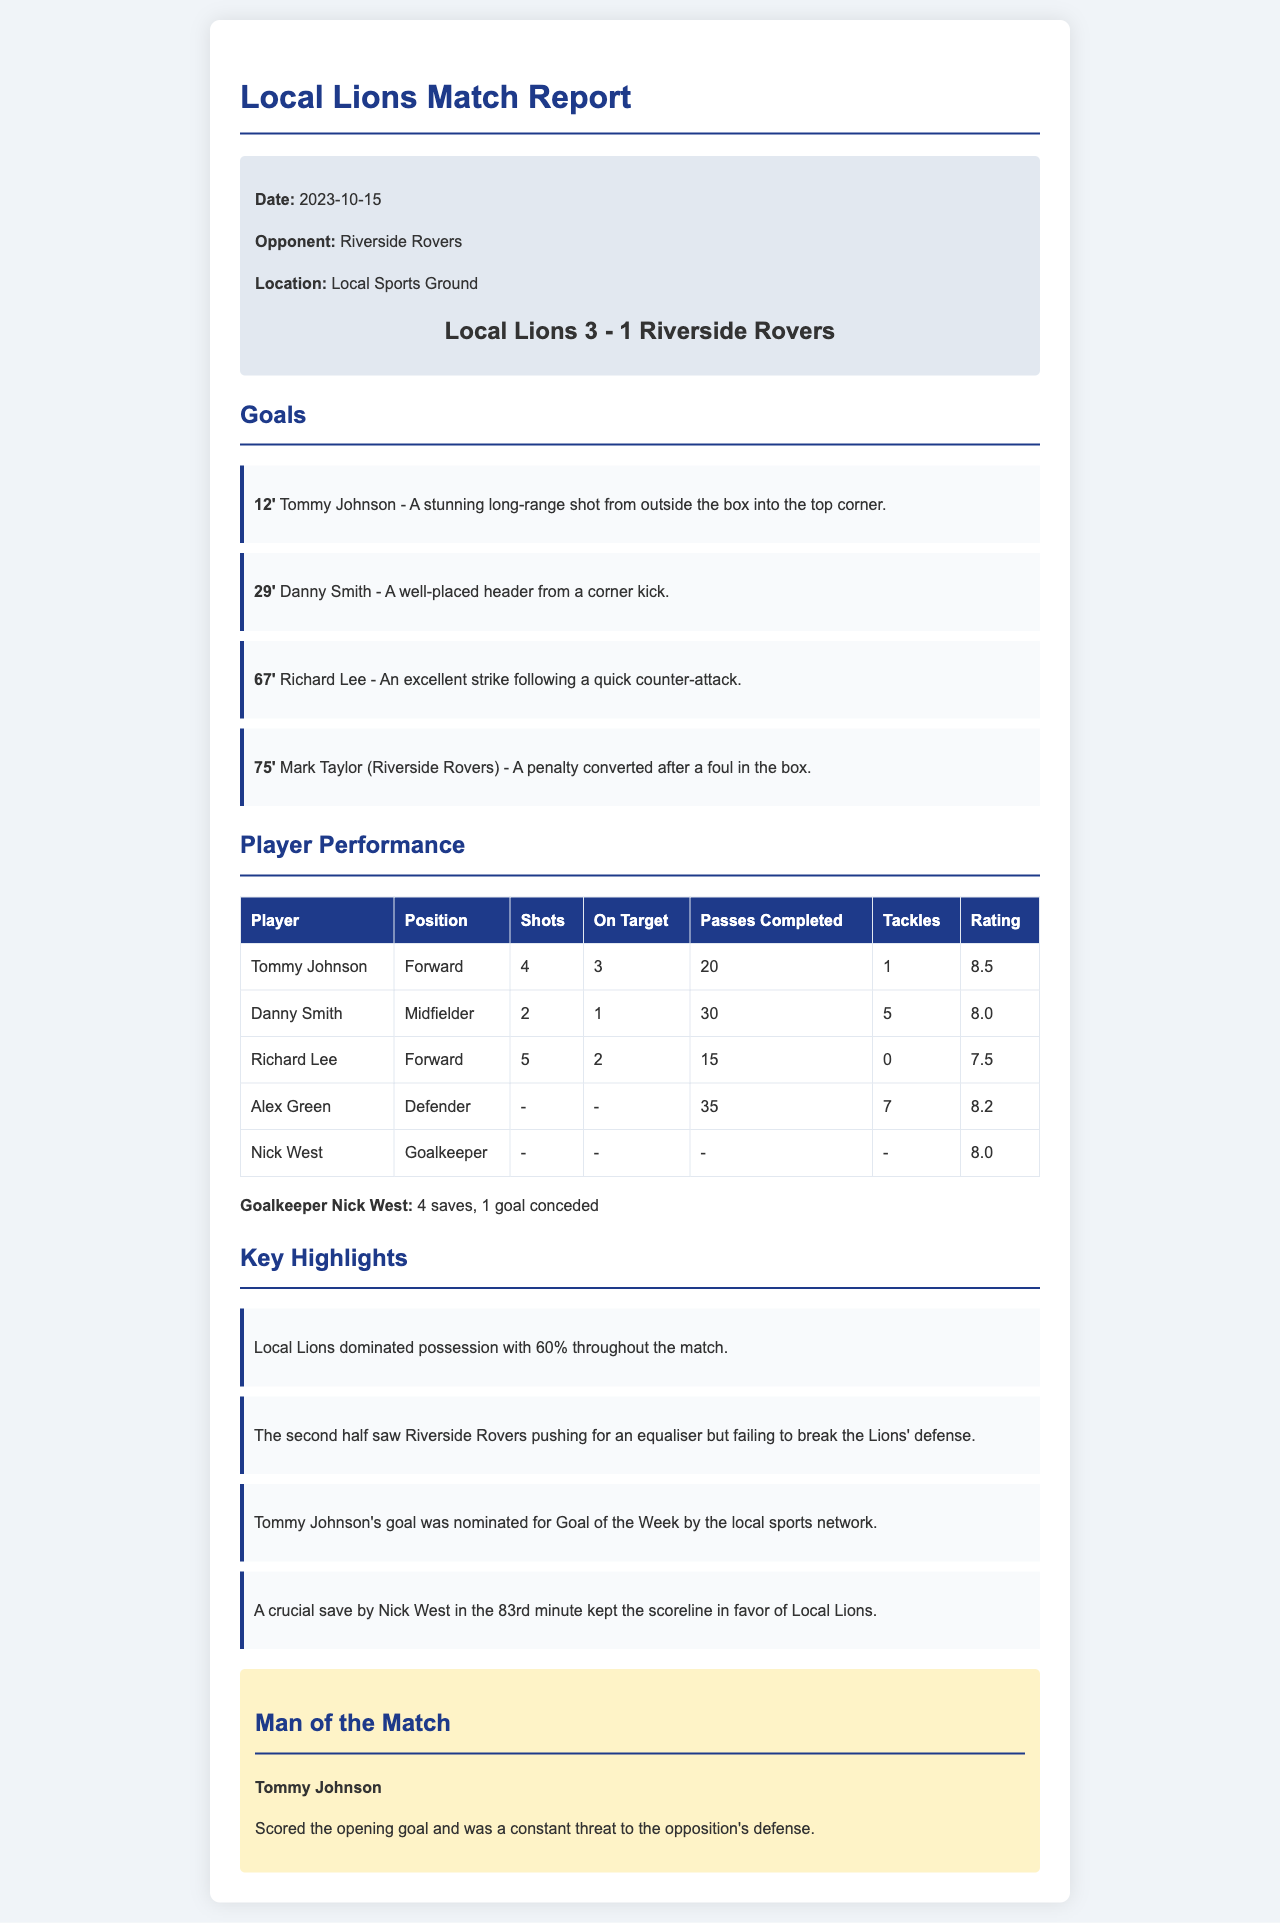What date was the match played? The date is clearly stated in the match info section of the report.
Answer: 2023-10-15 Who scored the first goal? The first goal is mentioned under the goals section, listing Tommy Johnson as the scorer.
Answer: Tommy Johnson What was the final score of the match? The final score is displayed prominently in the match-info section.
Answer: Local Lions 3 - 1 Riverside Rovers How many shots did Richard Lee take? The performance table indicates the number of shots taken by Richard Lee.
Answer: 5 What percentage of possession did the Local Lions have? The possession percentage is highlighted in the key highlights section of the report.
Answer: 60% Who was named Man of the Match? The Man of the Match is specifically identified towards the end of the document.
Answer: Tommy Johnson What key save did Nick West make? The highlights section notes a crucial save made by Nick West in the 83rd minute.
Answer: 83rd minute How many goals did Riverside Rovers score? The number of goals scored by Riverside Rovers can be found in the goals section.
Answer: 1 What was the passing performance of Danny Smith? The player performance table shows Danny Smith's completed passes.
Answer: 30 